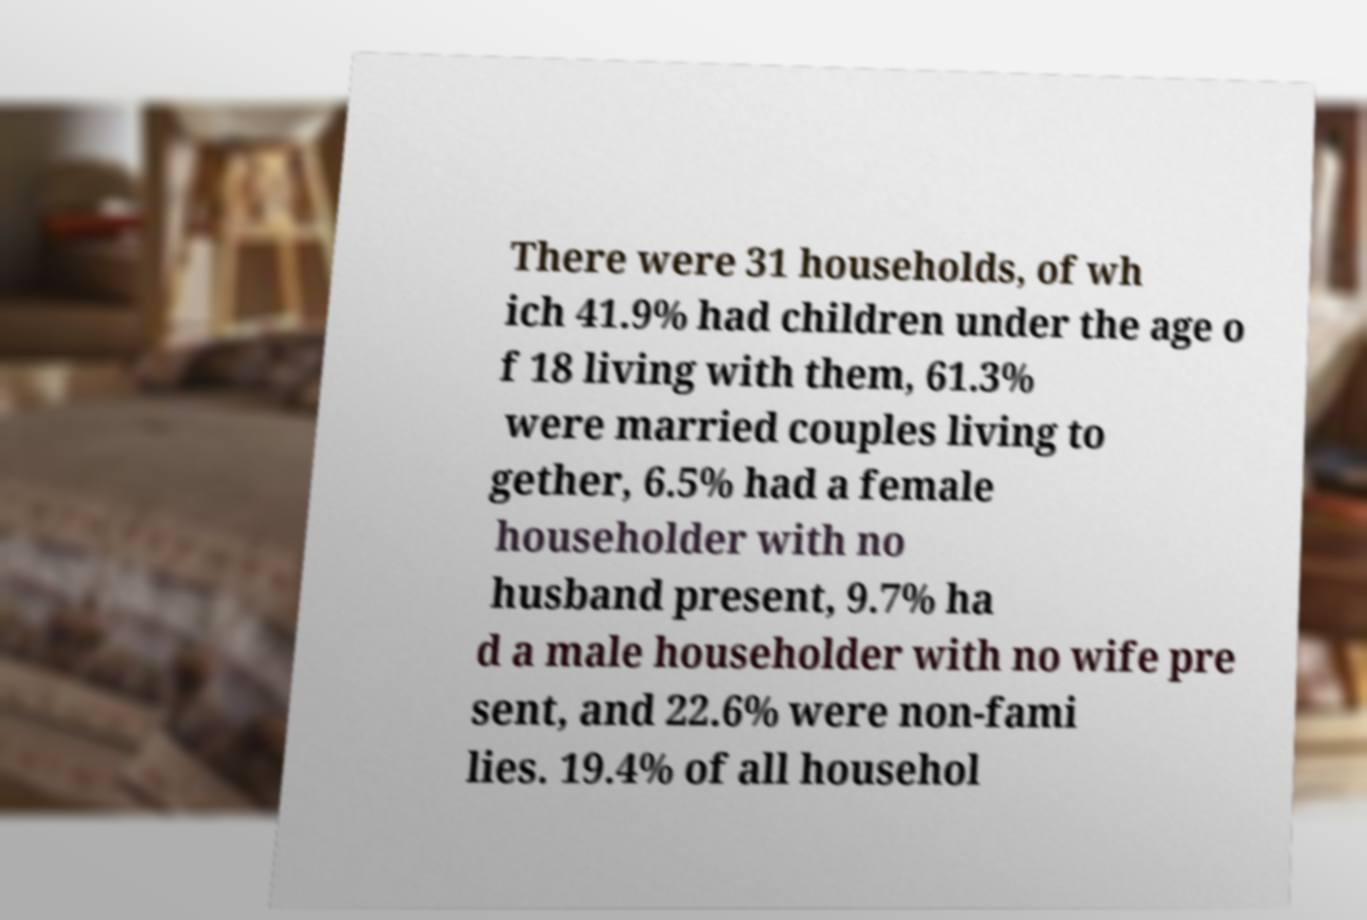What messages or text are displayed in this image? I need them in a readable, typed format. There were 31 households, of wh ich 41.9% had children under the age o f 18 living with them, 61.3% were married couples living to gether, 6.5% had a female householder with no husband present, 9.7% ha d a male householder with no wife pre sent, and 22.6% were non-fami lies. 19.4% of all househol 